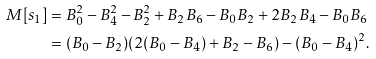<formula> <loc_0><loc_0><loc_500><loc_500>M [ s _ { 1 } ] & = B _ { 0 } ^ { 2 } - B _ { 4 } ^ { 2 } - B _ { 2 } ^ { 2 } + B _ { 2 } B _ { 6 } - B _ { 0 } B _ { 2 } + 2 B _ { 2 } B _ { 4 } - B _ { 0 } B _ { 6 } \\ & = ( B _ { 0 } - B _ { 2 } ) ( 2 ( B _ { 0 } - B _ { 4 } ) + B _ { 2 } - B _ { 6 } ) - ( B _ { 0 } - B _ { 4 } ) ^ { 2 } .</formula> 